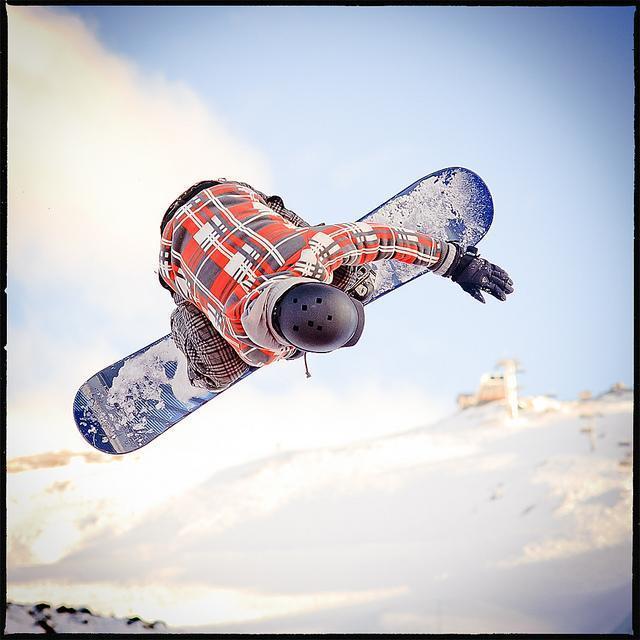How many giraffes are in the picture?
Give a very brief answer. 0. 